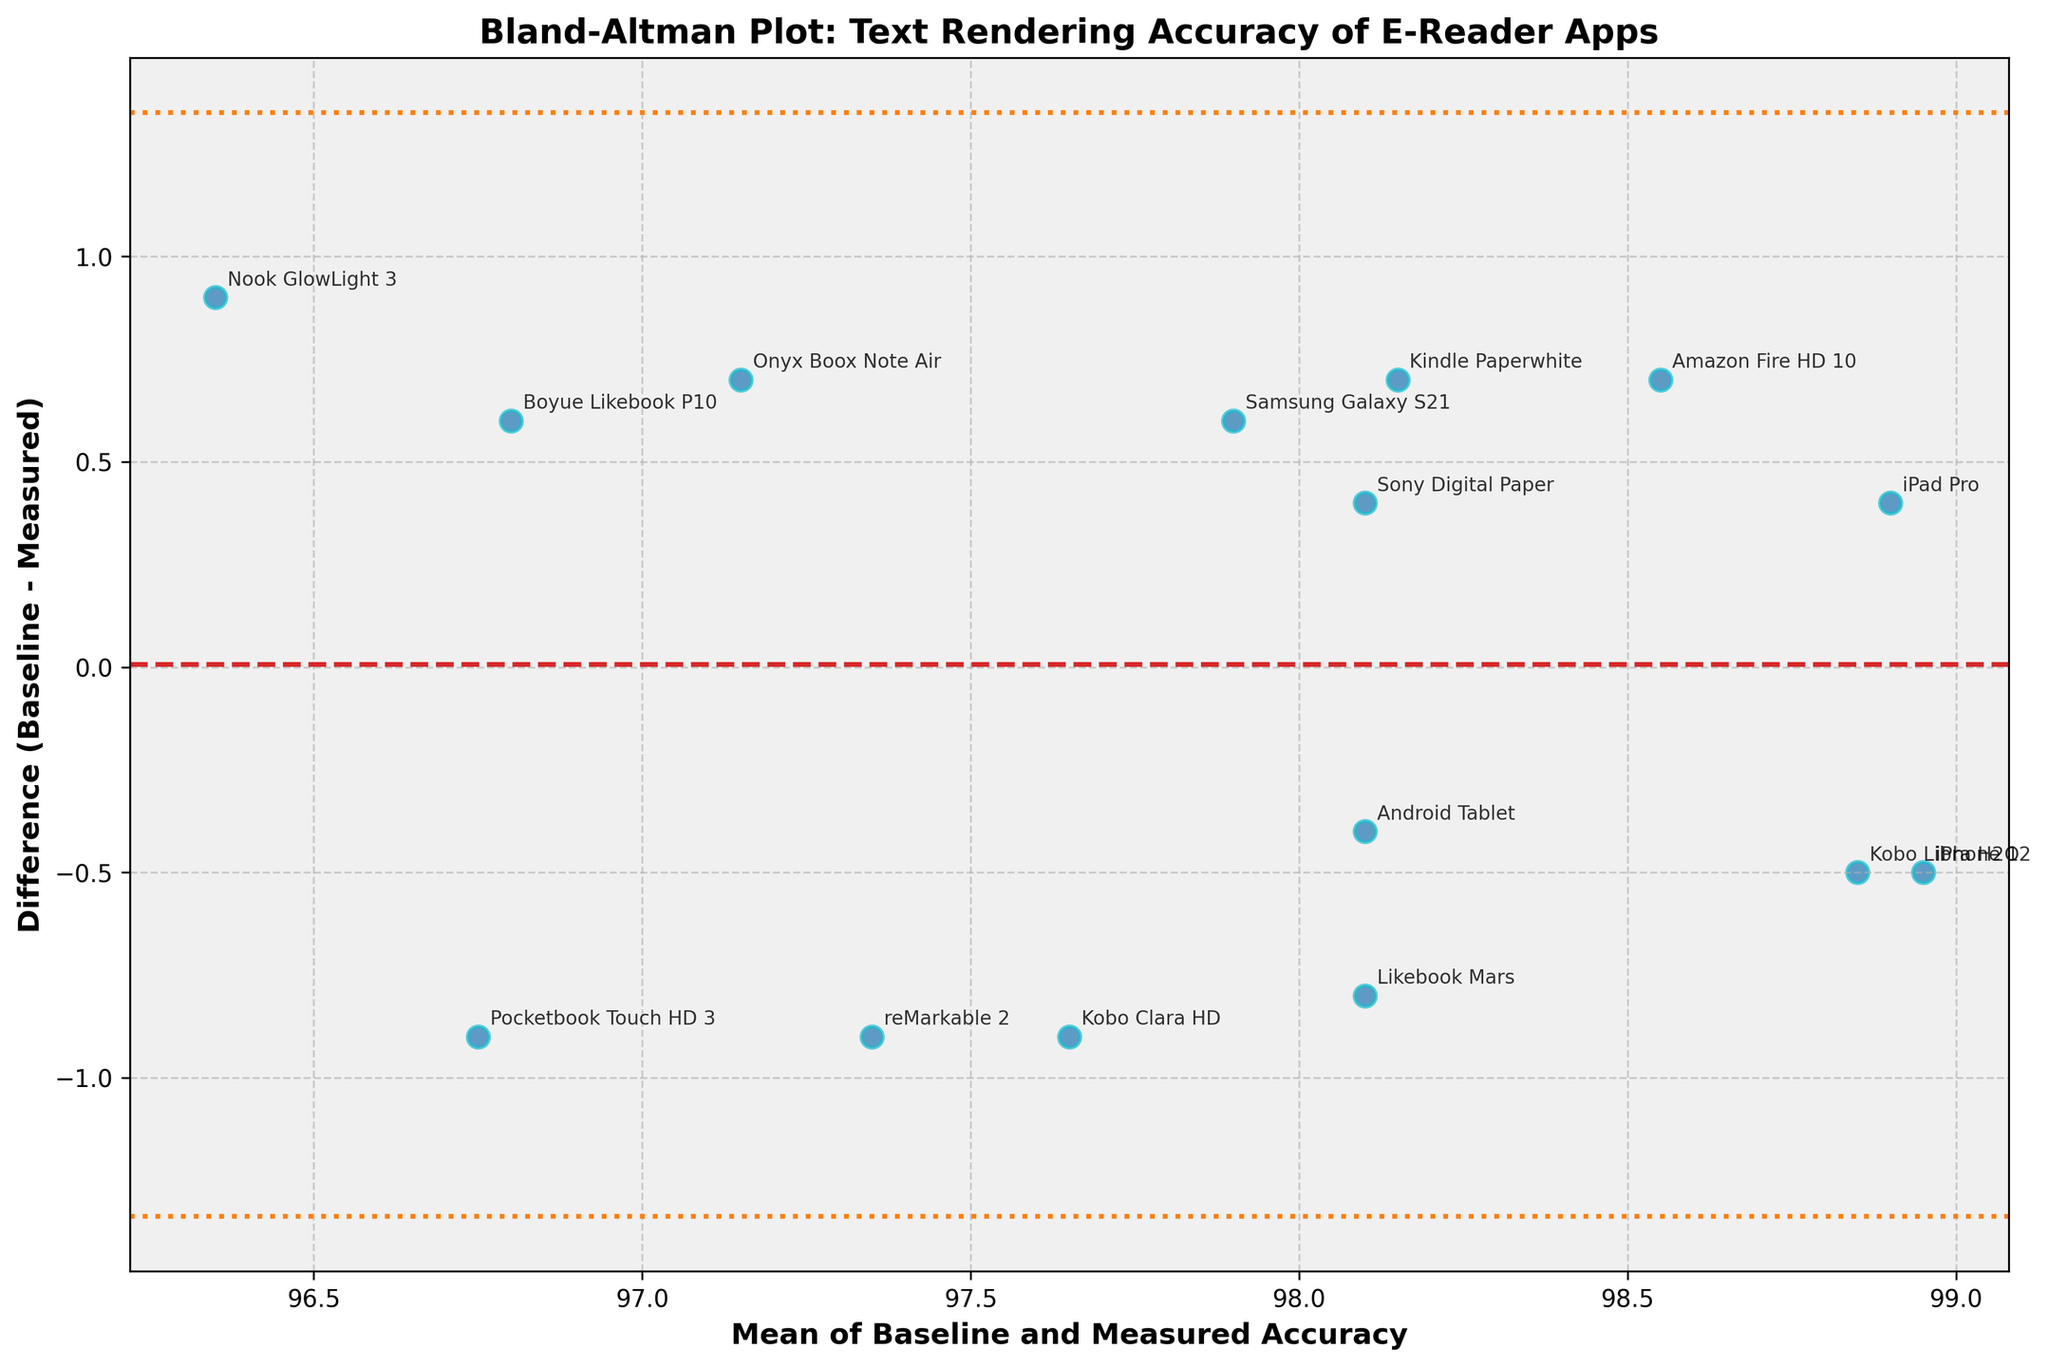What is the title of the figure? The title is usually found at the top of the figure. In this case, it reads "Bland-Altman Plot: Text Rendering Accuracy of E-Reader Apps".
Answer: Bland-Altman Plot: Text Rendering Accuracy of E-Reader Apps What are the labels for the x-axis and y-axis? The x-axis label is "Mean of Baseline and Measured Accuracy", and the y-axis label is "Difference (Baseline - Measured)". These labels usually explain the variables represented on the axes.
Answer: Mean of Baseline and Measured Accuracy, Difference (Baseline - Measured) How many data points are plotted in the figure? To find this, count the number of points (or devices) shown on the plot. From the data, there are 15 e-reader devices.
Answer: 15 Which device has the highest mean accuracy? Identify the device with the highest value on the x-axis. The iPad Pro has the highest mean accuracy of 98.90.
Answer: iPad Pro Which device shows the largest difference between baseline and measured accuracy? The device with the highest or lowest y-axis value has the largest difference. The Nook GlowLight 3 shows the largest difference (96.8 - 95.9 = 0.9, positioned lower).
Answer: Nook GlowLight 3 What is the mean difference in accuracy across all devices? The mean difference line is marked with a horizontal dashed line. You can also calculate this by averaging the differences of all data points. The mean difference is around -0.12.
Answer: -0.12 What are the upper and lower limits of agreement? These limits are represented by the dotted lines. They are typically ±1.96 standard deviations from the mean difference. Here, they are approximately -1.85 and 1.61.
Answer: -1.85 and 1.61 Which devices fall outside the limits of agreement? Look for devices plotted above the upper dotted line or below the lower dotted line. In this case, no devices fall outside the limits of agreement.
Answer: None How is the scatter plot visually distinguished in terms of color and size? The plot uses a single color for all points, with annotations in the same color but with an edge around them. Points are large (marker size 80) and have a slight transparency (alpha 0.7) to allow overlapping points to be visible.
Answer: Single color with annotations and edges Is there a noticeable trend in the difference as the mean accuracy increases? Observing the pattern of points, if there is an increasing or decreasing trend, it indicates a relationship. Here, there is no obvious upward or downward trend in differences.
Answer: No noticeable trend 